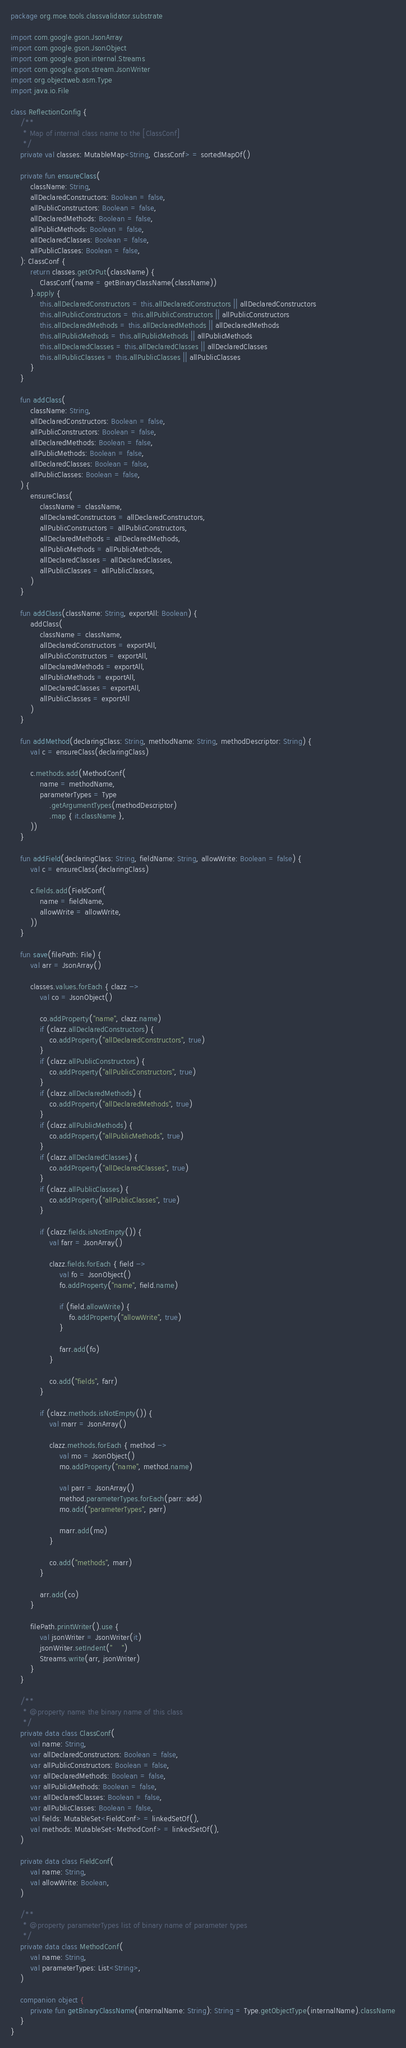Convert code to text. <code><loc_0><loc_0><loc_500><loc_500><_Kotlin_>package org.moe.tools.classvalidator.substrate

import com.google.gson.JsonArray
import com.google.gson.JsonObject
import com.google.gson.internal.Streams
import com.google.gson.stream.JsonWriter
import org.objectweb.asm.Type
import java.io.File

class ReflectionConfig {
    /**
     * Map of internal class name to the [ClassConf]
     */
    private val classes: MutableMap<String, ClassConf> = sortedMapOf()

    private fun ensureClass(
        className: String,
        allDeclaredConstructors: Boolean = false,
        allPublicConstructors: Boolean = false,
        allDeclaredMethods: Boolean = false,
        allPublicMethods: Boolean = false,
        allDeclaredClasses: Boolean = false,
        allPublicClasses: Boolean = false,
    ): ClassConf {
        return classes.getOrPut(className) {
            ClassConf(name = getBinaryClassName(className))
        }.apply {
            this.allDeclaredConstructors = this.allDeclaredConstructors || allDeclaredConstructors
            this.allPublicConstructors = this.allPublicConstructors || allPublicConstructors
            this.allDeclaredMethods = this.allDeclaredMethods || allDeclaredMethods
            this.allPublicMethods = this.allPublicMethods || allPublicMethods
            this.allDeclaredClasses = this.allDeclaredClasses || allDeclaredClasses
            this.allPublicClasses = this.allPublicClasses || allPublicClasses
        }
    }

    fun addClass(
        className: String,
        allDeclaredConstructors: Boolean = false,
        allPublicConstructors: Boolean = false,
        allDeclaredMethods: Boolean = false,
        allPublicMethods: Boolean = false,
        allDeclaredClasses: Boolean = false,
        allPublicClasses: Boolean = false,
    ) {
        ensureClass(
            className = className,
            allDeclaredConstructors = allDeclaredConstructors,
            allPublicConstructors = allPublicConstructors,
            allDeclaredMethods = allDeclaredMethods,
            allPublicMethods = allPublicMethods,
            allDeclaredClasses = allDeclaredClasses,
            allPublicClasses = allPublicClasses,
        )
    }

    fun addClass(className: String, exportAll: Boolean) {
        addClass(
            className = className,
            allDeclaredConstructors = exportAll,
            allPublicConstructors = exportAll,
            allDeclaredMethods = exportAll,
            allPublicMethods = exportAll,
            allDeclaredClasses = exportAll,
            allPublicClasses = exportAll
        )
    }

    fun addMethod(declaringClass: String, methodName: String, methodDescriptor: String) {
        val c = ensureClass(declaringClass)

        c.methods.add(MethodConf(
            name = methodName,
            parameterTypes = Type
                .getArgumentTypes(methodDescriptor)
                .map { it.className },
        ))
    }

    fun addField(declaringClass: String, fieldName: String, allowWrite: Boolean = false) {
        val c = ensureClass(declaringClass)

        c.fields.add(FieldConf(
            name = fieldName,
            allowWrite = allowWrite,
        ))
    }

    fun save(filePath: File) {
        val arr = JsonArray()

        classes.values.forEach { clazz ->
            val co = JsonObject()

            co.addProperty("name", clazz.name)
            if (clazz.allDeclaredConstructors) {
                co.addProperty("allDeclaredConstructors", true)
            }
            if (clazz.allPublicConstructors) {
                co.addProperty("allPublicConstructors", true)
            }
            if (clazz.allDeclaredMethods) {
                co.addProperty("allDeclaredMethods", true)
            }
            if (clazz.allPublicMethods) {
                co.addProperty("allPublicMethods", true)
            }
            if (clazz.allDeclaredClasses) {
                co.addProperty("allDeclaredClasses", true)
            }
            if (clazz.allPublicClasses) {
                co.addProperty("allPublicClasses", true)
            }

            if (clazz.fields.isNotEmpty()) {
                val farr = JsonArray()

                clazz.fields.forEach { field ->
                    val fo = JsonObject()
                    fo.addProperty("name", field.name)

                    if (field.allowWrite) {
                        fo.addProperty("allowWrite", true)
                    }

                    farr.add(fo)
                }

                co.add("fields", farr)
            }

            if (clazz.methods.isNotEmpty()) {
                val marr = JsonArray()

                clazz.methods.forEach { method ->
                    val mo = JsonObject()
                    mo.addProperty("name", method.name)

                    val parr = JsonArray()
                    method.parameterTypes.forEach(parr::add)
                    mo.add("parameterTypes", parr)

                    marr.add(mo)
                }

                co.add("methods", marr)
            }

            arr.add(co)
        }

        filePath.printWriter().use {
            val jsonWriter = JsonWriter(it)
            jsonWriter.setIndent("    ")
            Streams.write(arr, jsonWriter)
        }
    }

    /**
     * @property name the binary name of this class
     */
    private data class ClassConf(
        val name: String,
        var allDeclaredConstructors: Boolean = false,
        var allPublicConstructors: Boolean = false,
        var allDeclaredMethods: Boolean = false,
        var allPublicMethods: Boolean = false,
        var allDeclaredClasses: Boolean = false,
        var allPublicClasses: Boolean = false,
        val fields: MutableSet<FieldConf> = linkedSetOf(),
        val methods: MutableSet<MethodConf> = linkedSetOf(),
    )

    private data class FieldConf(
        val name: String,
        val allowWrite: Boolean,
    )

    /**
     * @property parameterTypes list of binary name of parameter types
     */
    private data class MethodConf(
        val name: String,
        val parameterTypes: List<String>,
    )

    companion object {
        private fun getBinaryClassName(internalName: String): String = Type.getObjectType(internalName).className
    }
}
</code> 